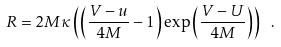Convert formula to latex. <formula><loc_0><loc_0><loc_500><loc_500>R = 2 M \kappa \left ( \left ( \frac { V - u } { 4 M } - 1 \right ) \exp \left ( \frac { V - U } { 4 M } \right ) \right ) \ .</formula> 